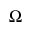<formula> <loc_0><loc_0><loc_500><loc_500>\Omega</formula> 